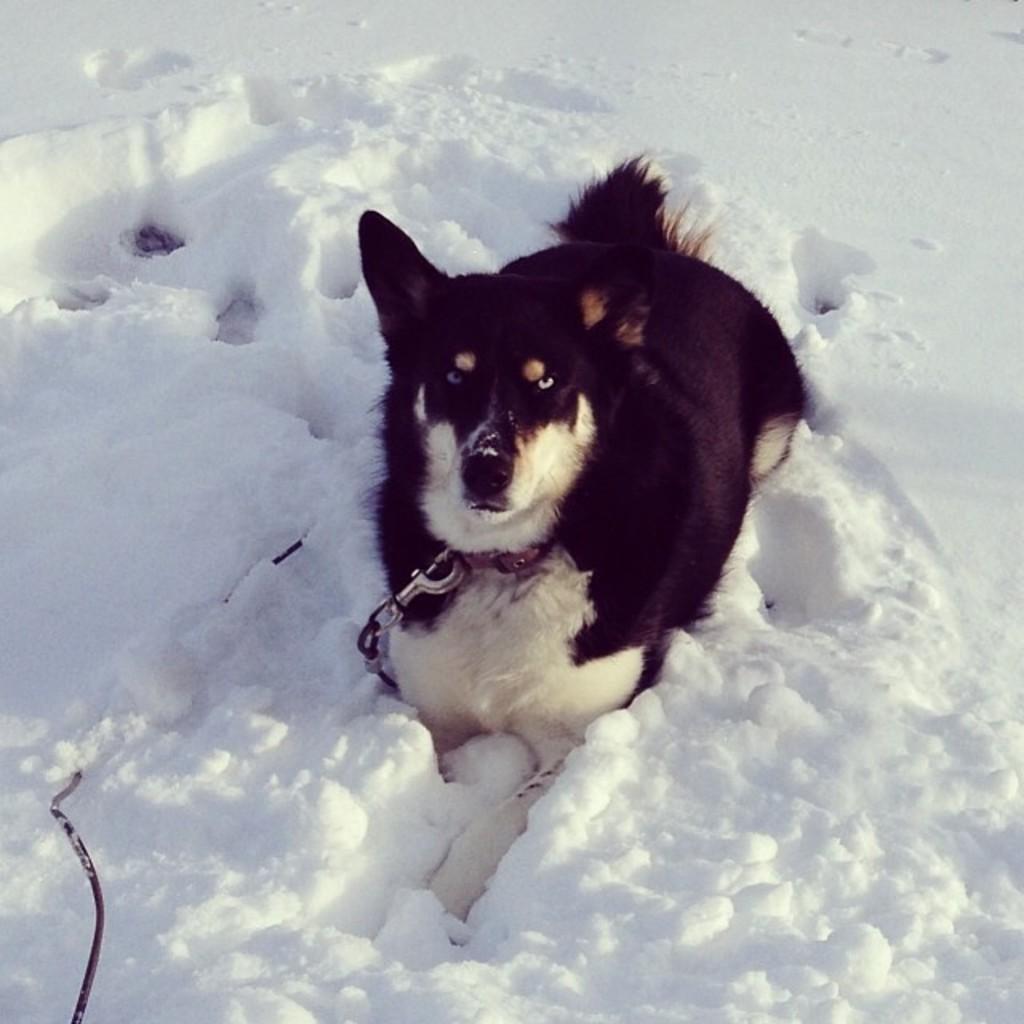Can you describe this image briefly? In the center of the image there is a dog. At the bottom of the image there is snow. 